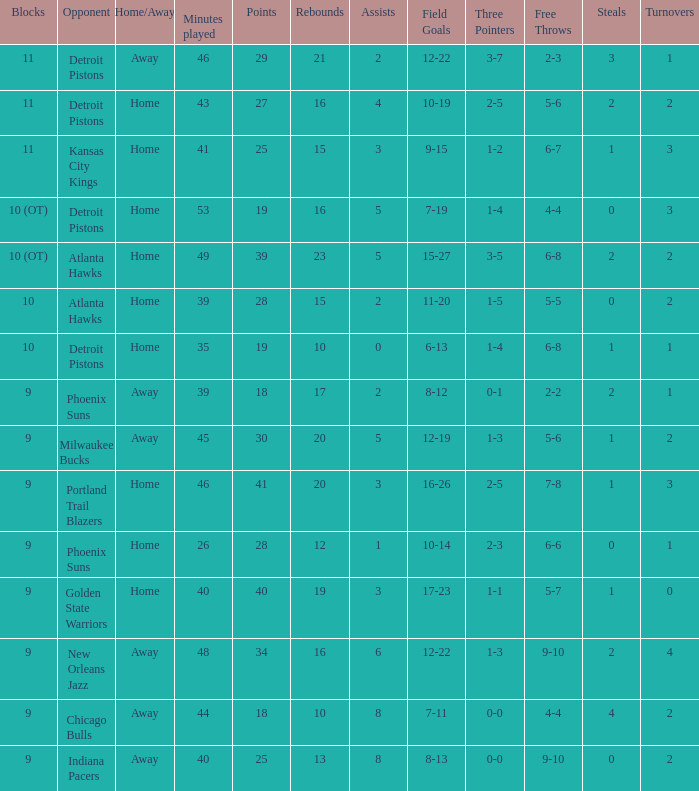How many minutes were played when there were 18 points and the opponent was Chicago Bulls? 1.0. 